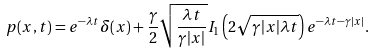<formula> <loc_0><loc_0><loc_500><loc_500>p ( x , t ) = e ^ { - \lambda t } \delta ( x ) + \frac { \gamma } { 2 } \sqrt { \frac { \lambda t } { \gamma | x | } } I _ { 1 } \left ( 2 \sqrt { \gamma | x | \lambda t } \right ) e ^ { - \lambda t - \gamma | x | } .</formula> 